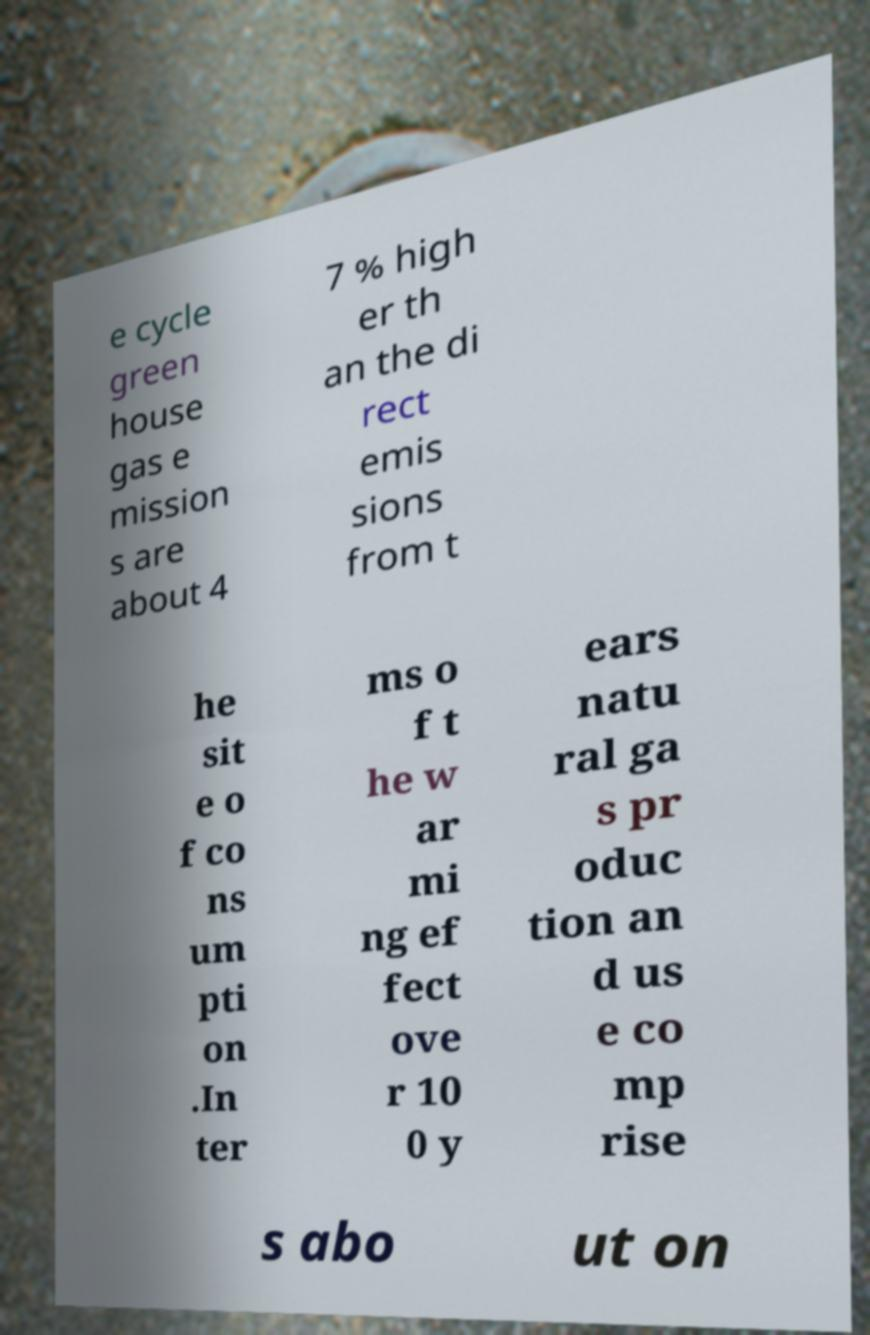Please read and relay the text visible in this image. What does it say? e cycle green house gas e mission s are about 4 7 % high er th an the di rect emis sions from t he sit e o f co ns um pti on .In ter ms o f t he w ar mi ng ef fect ove r 10 0 y ears natu ral ga s pr oduc tion an d us e co mp rise s abo ut on 